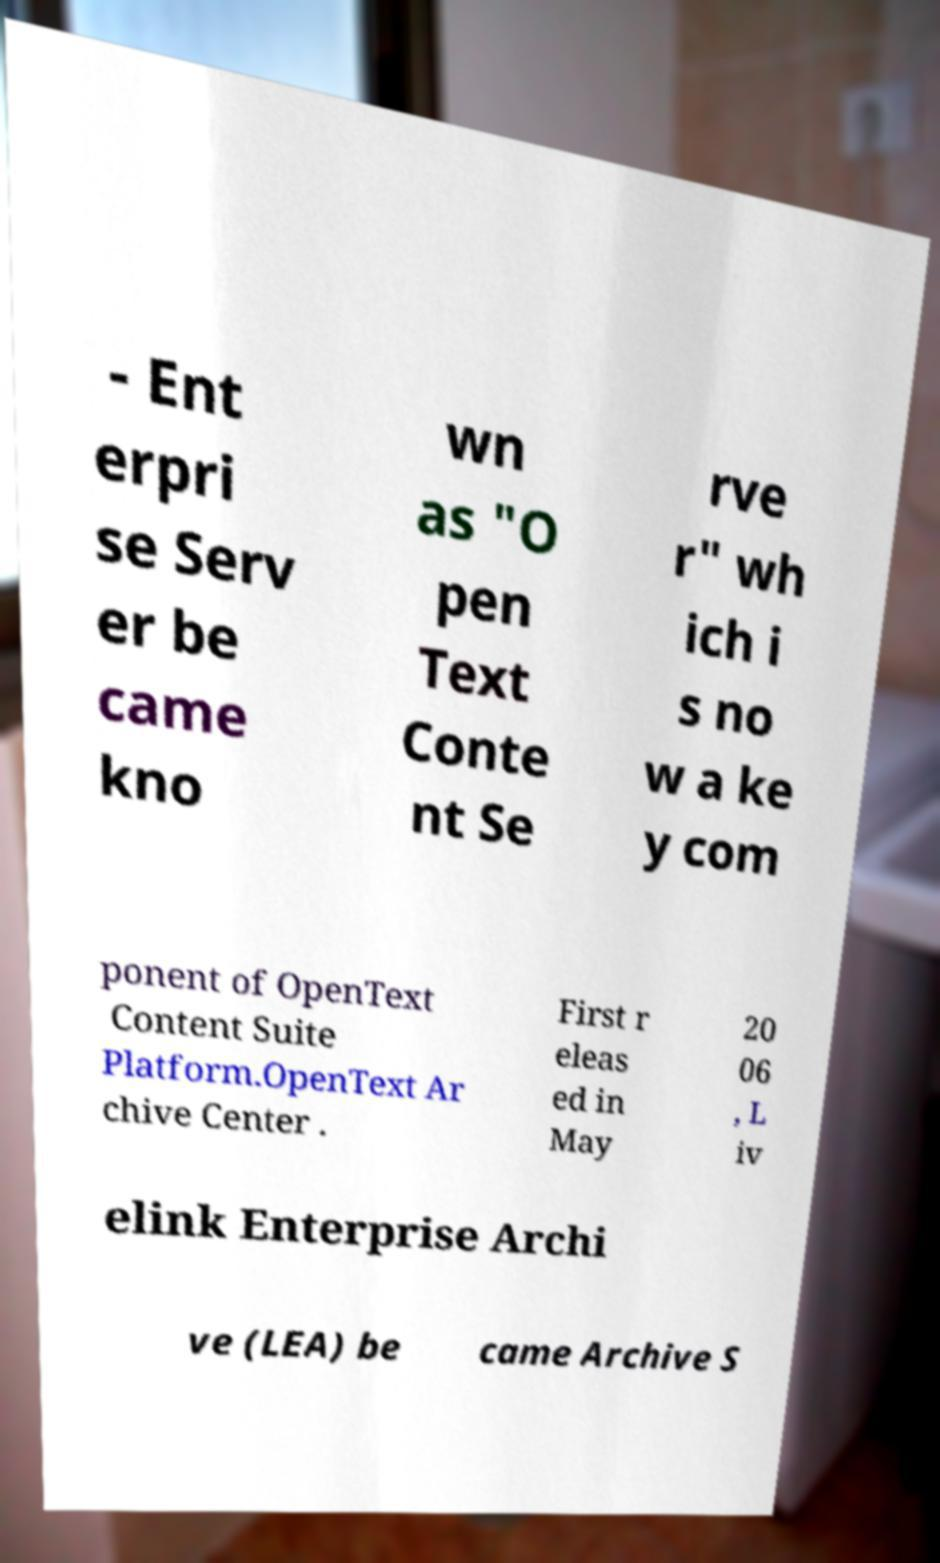Please read and relay the text visible in this image. What does it say? - Ent erpri se Serv er be came kno wn as "O pen Text Conte nt Se rve r" wh ich i s no w a ke y com ponent of OpenText Content Suite Platform.OpenText Ar chive Center . First r eleas ed in May 20 06 , L iv elink Enterprise Archi ve (LEA) be came Archive S 